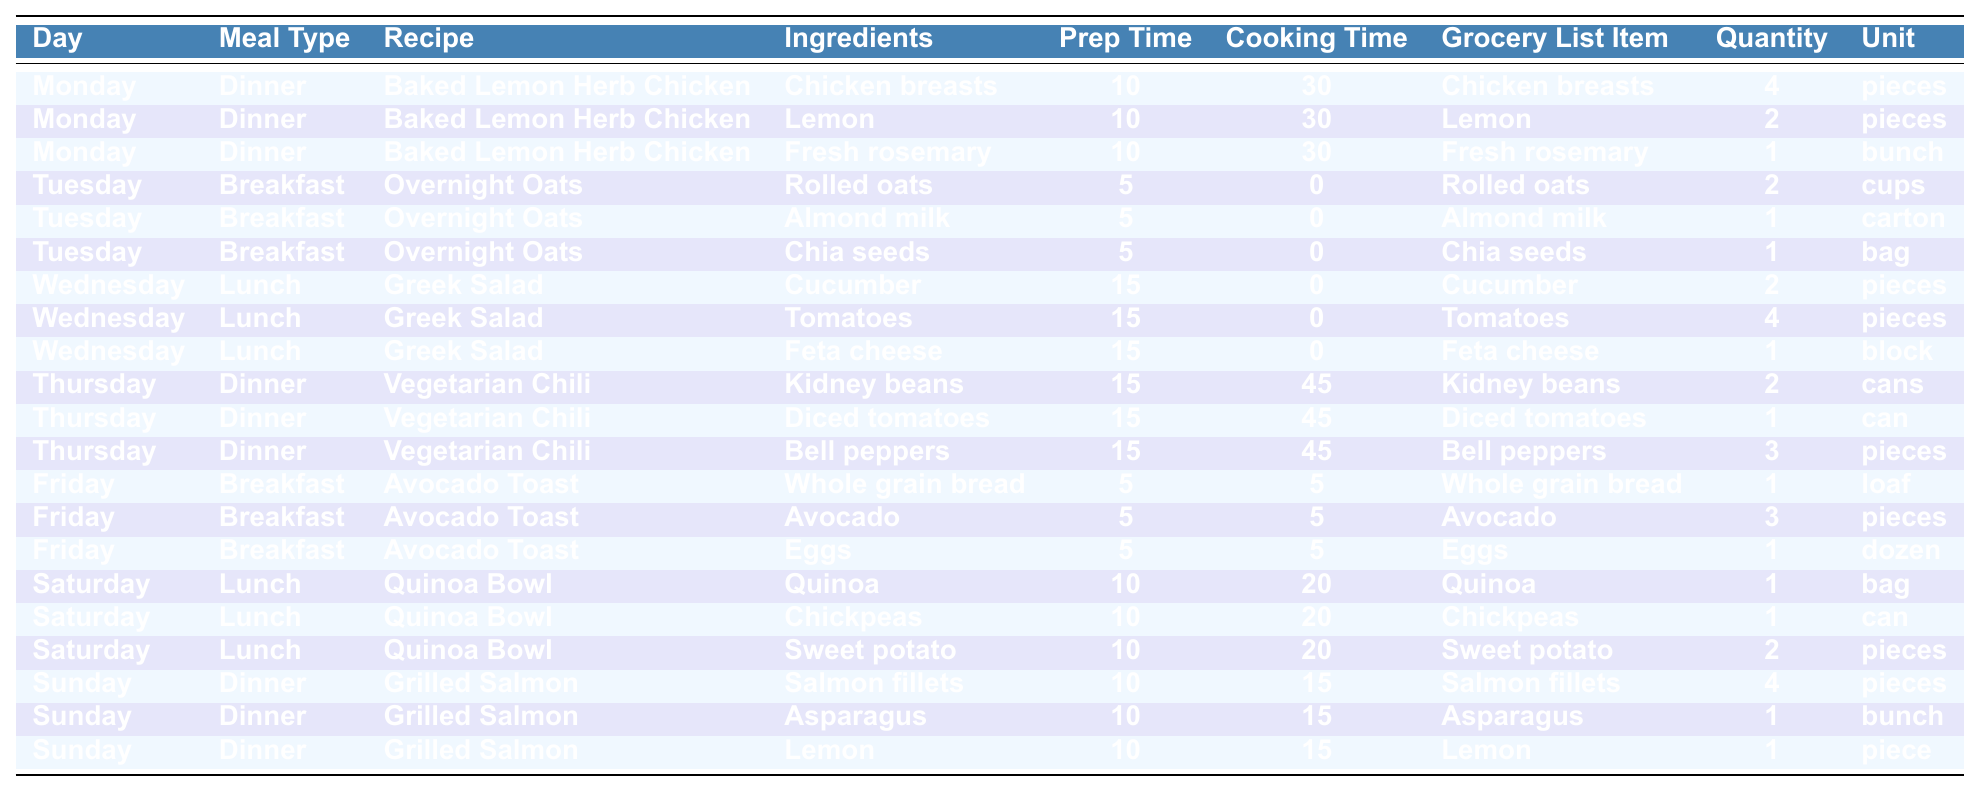What is the total number of recipes included in the meal plan? There are 12 unique recipes listed in the table: Baked Lemon Herb Chicken, Overnight Oats, Greek Salad, Vegetarian Chili, Avocado Toast, Quinoa Bowl, and Grilled Salmon. Counting each unique entry gives the total.
Answer: 12 How many types of meals are planned for Wednesday? The table lists only one meal type for Wednesday, which is Lunch, as shown under the Meal Type column.
Answer: 1 What ingredient is used in both the Baked Lemon Herb Chicken and Grilled Salmon recipes? Lemon is included in both recipes; it appears twice, once under Baked Lemon Herb Chicken and once under Grilled Salmon.
Answer: Lemon Which meal requires the longest cooking time? The Vegetarian Chili has the longest cooking time of 45 minutes, as indicated in its Cooking Time column.
Answer: 45 minutes What is the total quantity of protein sources listed across all recipes? The protein sources include Chicken breasts (4 pieces), Eggs (1 dozen), Salmon fillets (4 pieces), and Chickpeas (1 can). Converting 1 dozen to pieces (12), the total is 4 + 12 + 4 + 1 = 21.
Answer: 21 pieces How many total different ingredients are needed for Friday's breakfast? For Avocado Toast on Friday, three ingredients are listed: Whole grain bread, Avocado, and Eggs. The number of different ingredients adds up to three.
Answer: 3 Is there a vegetarian recipe included in the meal plan? Yes, the Vegetarian Chili is classified as a vegetarian recipe according to the Meal Type and Recipe columns.
Answer: Yes Which day has a meal that includes Feta cheese? The Greek Salad, which contains Feta cheese, is scheduled for Wednesday. This can be confirmed by checking the Recipe and Ingredients columns.
Answer: Wednesday How many pieces of fruit are on the grocery list for the entire week? The grocery list includes 2 Lemons for Monday, 3 Avocados for Friday, and 1 Lemon for Sunday, totaling 2 + 3 + 1 = 6 pieces of fruit.
Answer: 6 pieces What is the average prep time for all the meals listed in the table? The prep times for each meal are: 10, 10, 10, 5, 5, 5, 15, 15, 15, 15, 5, 10, totaling 115 minutes. There are 12 meals, so the average is 115/12 = approximately 9.58.
Answer: 9.58 minutes 